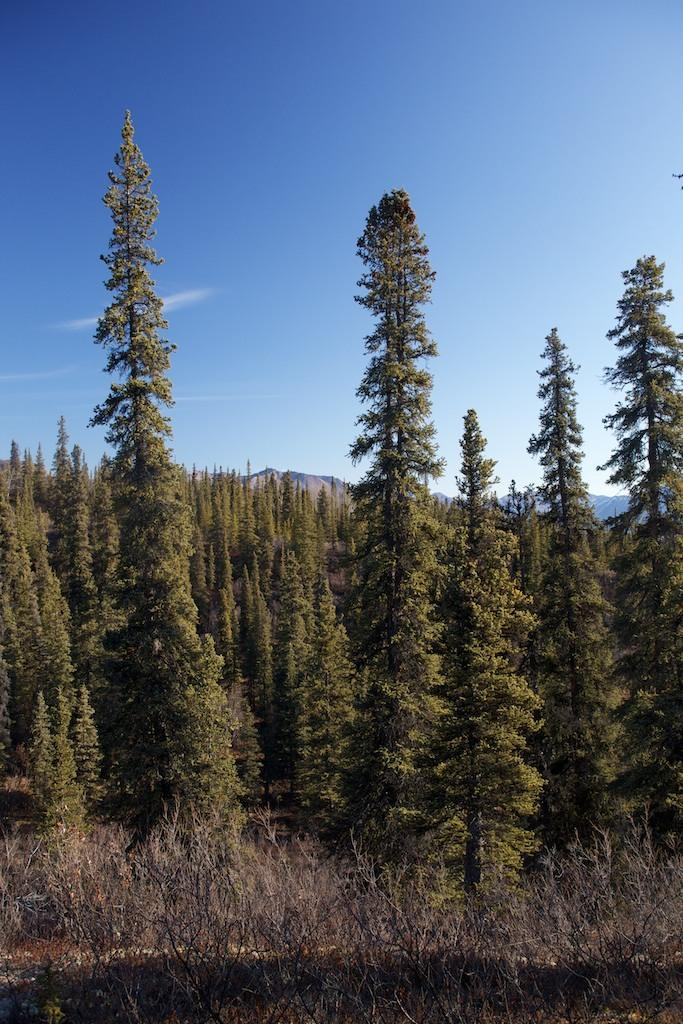What is located in the center of the image? There are trees in the center of the image. What type of vegetation is at the bottom of the image? There are dry plants at the bottom of the image. What is visible at the top of the image? The sky is visible at the top of the image. How many knees can be seen in the image? There are no knees visible in the image. What type of metal is present in the image? There is no metal, such as copper, present in the image. 